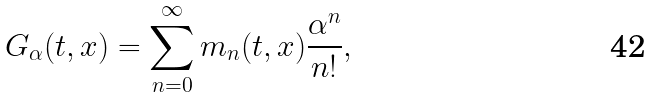<formula> <loc_0><loc_0><loc_500><loc_500>G _ { \alpha } ( t , x ) = \sum _ { n = 0 } ^ { \infty } m _ { n } ( t , x ) \frac { \alpha ^ { n } } { n ! } ,</formula> 